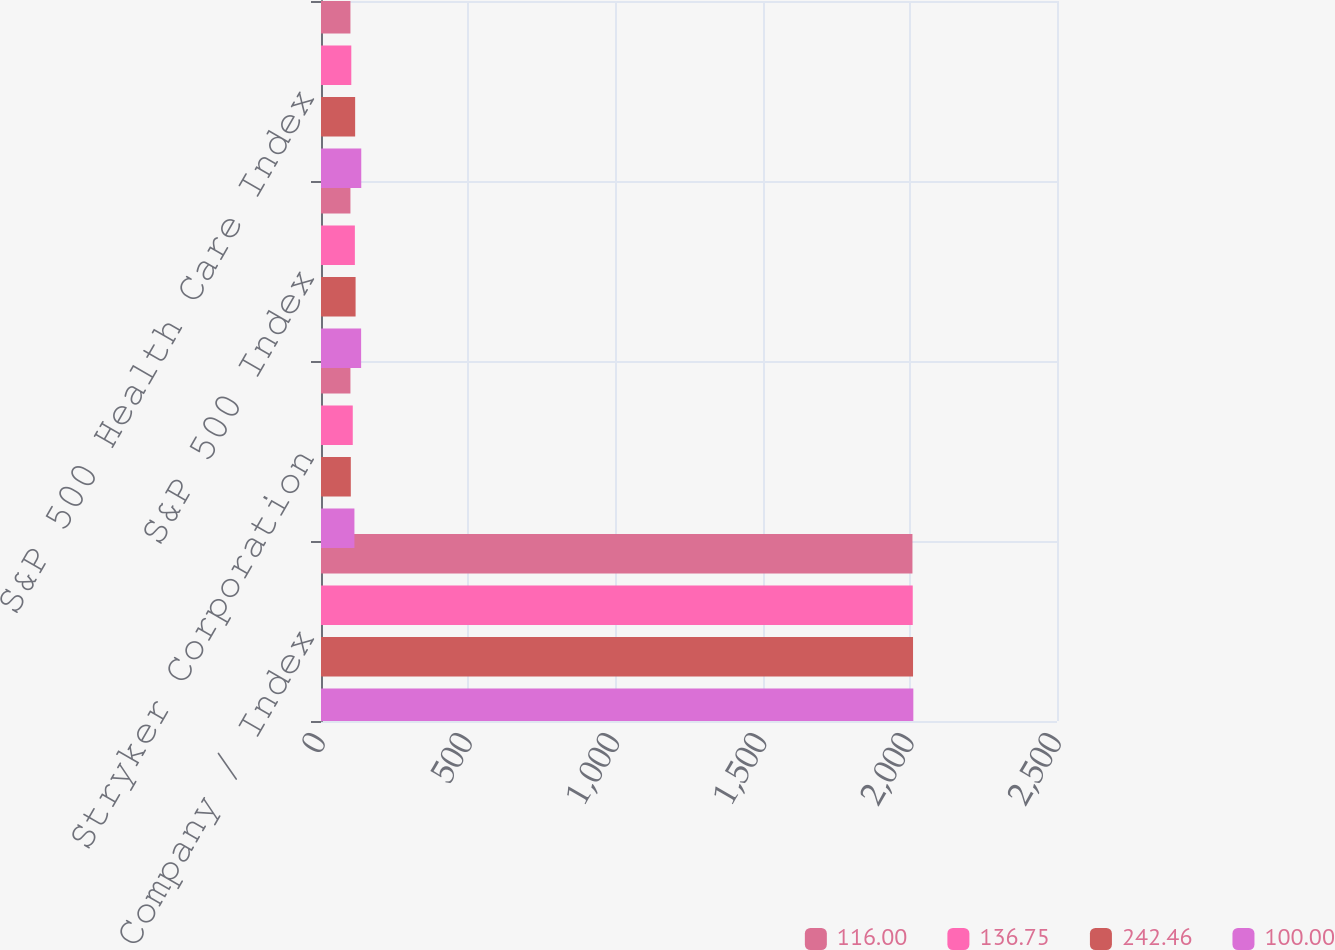<chart> <loc_0><loc_0><loc_500><loc_500><stacked_bar_chart><ecel><fcel>Company / Index<fcel>Stryker Corporation<fcel>S&P 500 Index<fcel>S&P 500 Health Care Index<nl><fcel>116<fcel>2009<fcel>100<fcel>100<fcel>100<nl><fcel>136.75<fcel>2010<fcel>107.89<fcel>115.06<fcel>102.9<nl><fcel>242.46<fcel>2011<fcel>101.29<fcel>117.49<fcel>116<nl><fcel>100<fcel>2012<fcel>113.54<fcel>136.3<fcel>136.75<nl></chart> 